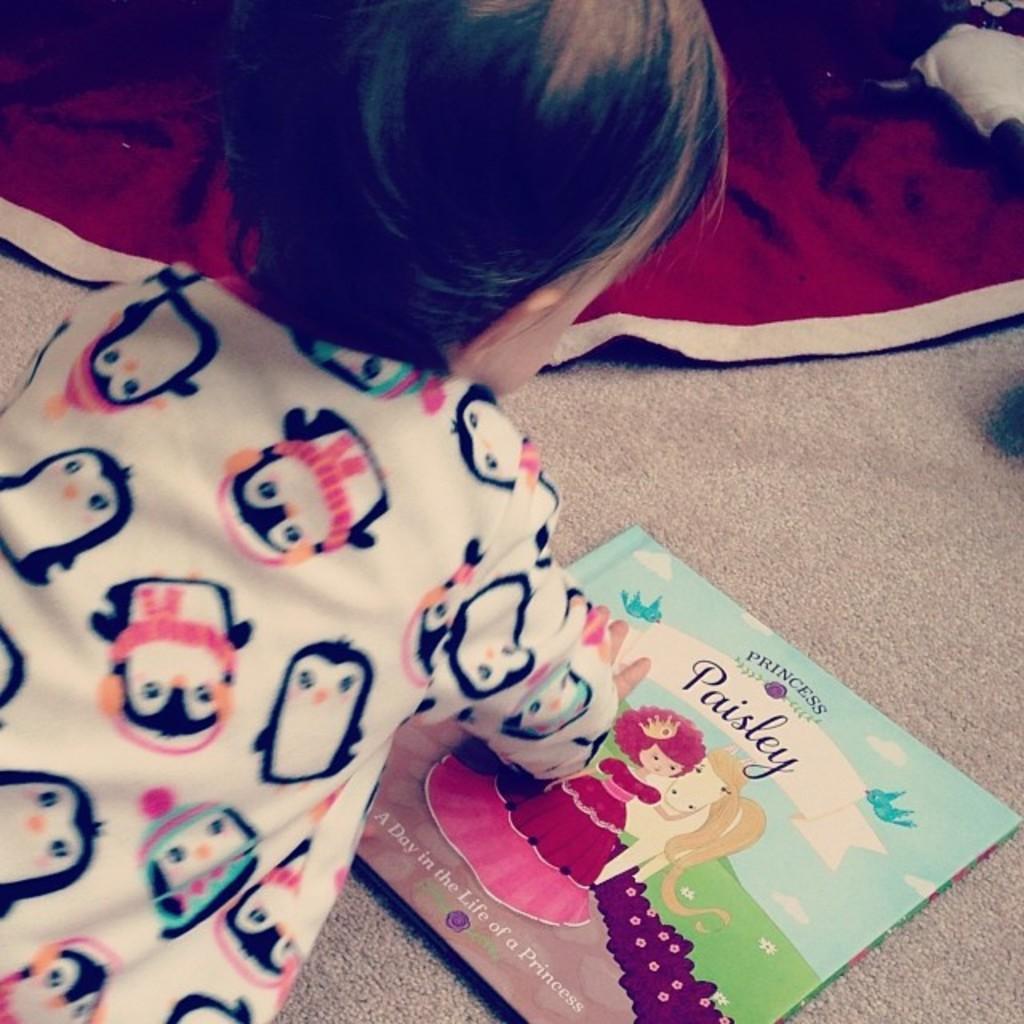Could you give a brief overview of what you see in this image? In this image I see a baby over here who is wearing white color dress and I see a book over here on which there is something written and I see the cartoon characters and I see the floor and I see the red and white color cloth over here. 